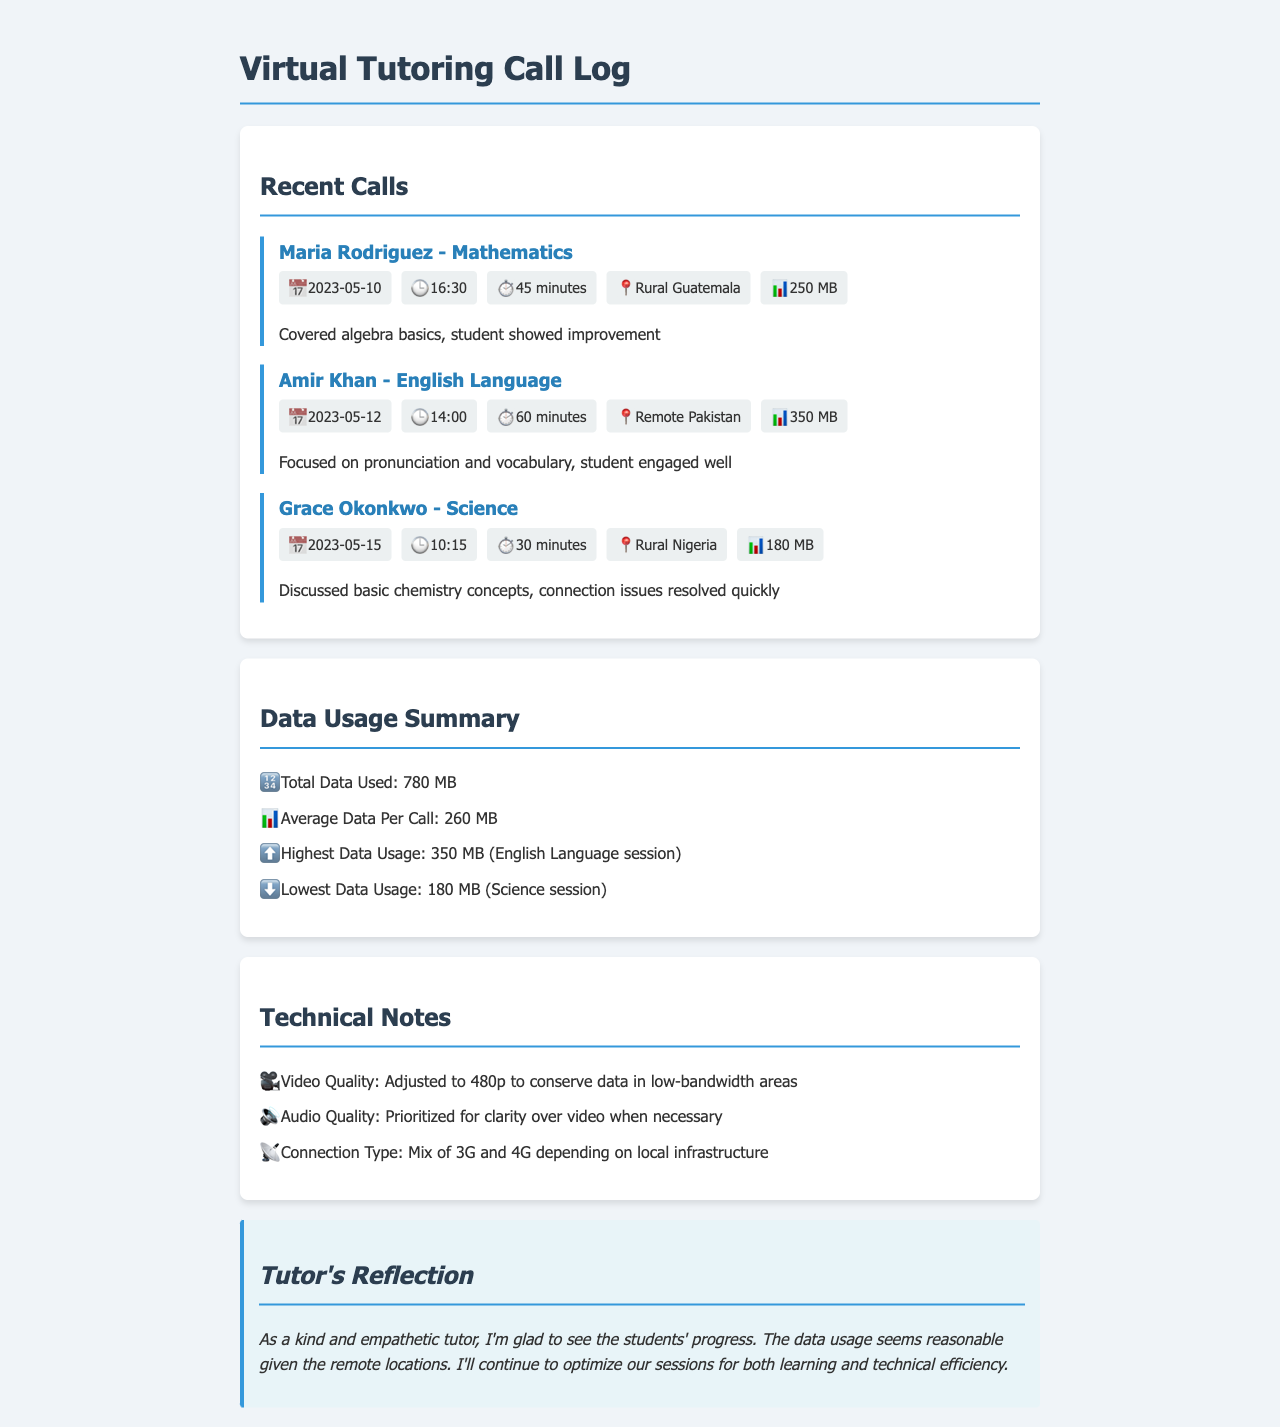What is the total data used? The total data used is the sum of all data from the calls listed in the document, which is 250 MB + 350 MB + 180 MB = 780 MB.
Answer: 780 MB Who is the student for the English Language session? The student's name for the English Language session is mentioned in the call log.
Answer: Amir Khan When was the Mathematics session held? The date of the Mathematics session is specified in the call details of the document.
Answer: 2023-05-10 What is the highest data usage recorded? The highest data usage is identified in the Data Usage Summary section of the document.
Answer: 350 MB How long was the Science session? The duration of the Science session can be found in the call details provided for that specific call.
Answer: 30 minutes Which subject had the lowest data usage? The subject with the lowest data usage is identified in the Data Usage Summary section, comparing all subjects listed.
Answer: Science What video quality adjustment was made? The video quality adjustment is noted in the Technical Notes section, specifying the resolution for the video calls.
Answer: 480p What connection types were used during the calls? The varying connection types are mentioned in the Technical Notes section of the document.
Answer: 3G and 4G What is the main reflection of the tutor? The tutor's reflection summarizes their thoughts on the progress of the students and technical aspects of the session.
Answer: Glad to see the students' progress 